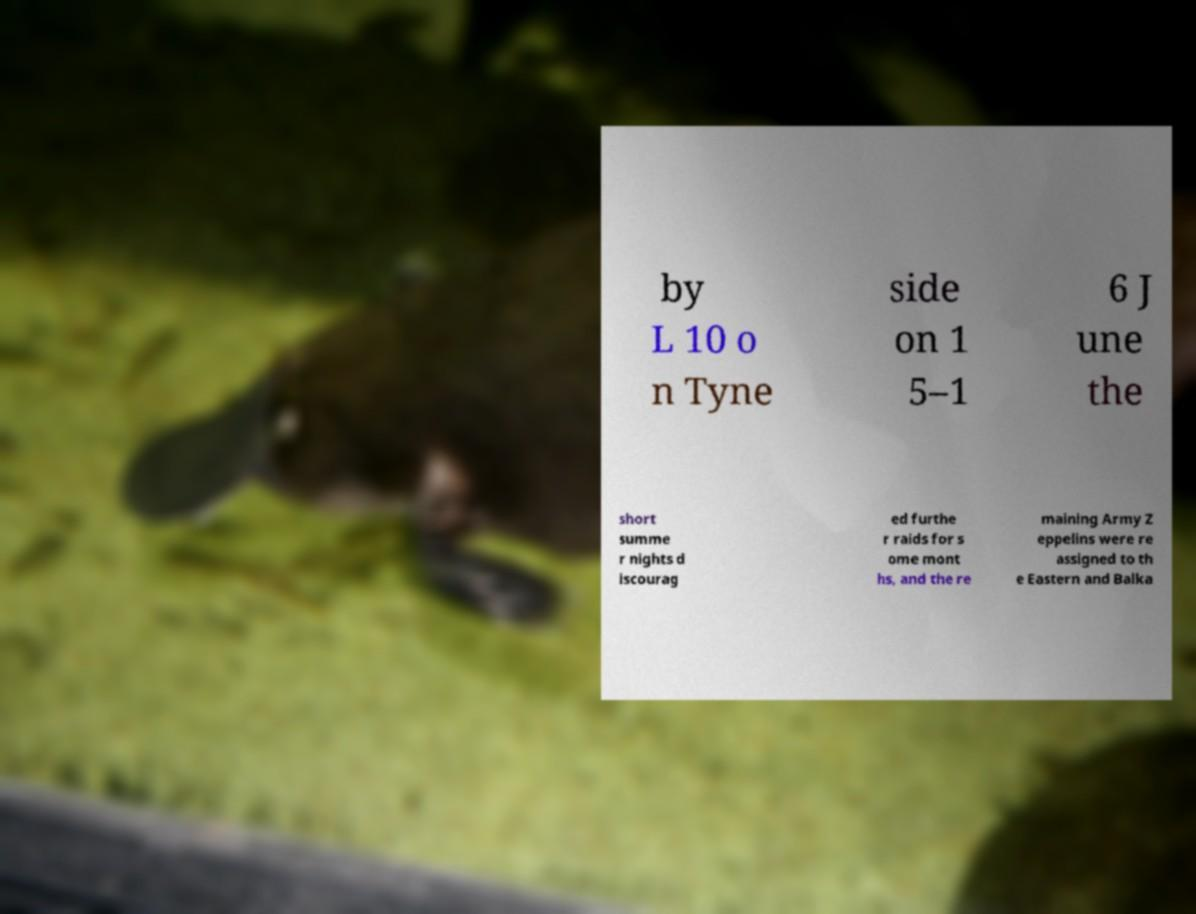Could you assist in decoding the text presented in this image and type it out clearly? by L 10 o n Tyne side on 1 5–1 6 J une the short summe r nights d iscourag ed furthe r raids for s ome mont hs, and the re maining Army Z eppelins were re assigned to th e Eastern and Balka 